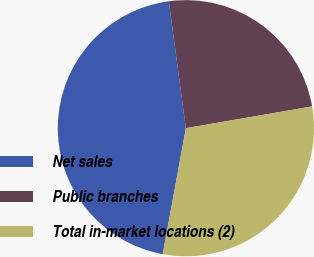Convert chart to OTSL. <chart><loc_0><loc_0><loc_500><loc_500><pie_chart><fcel>Net sales<fcel>Public branches<fcel>Total in-market locations (2)<nl><fcel>44.98%<fcel>24.41%<fcel>30.61%<nl></chart> 